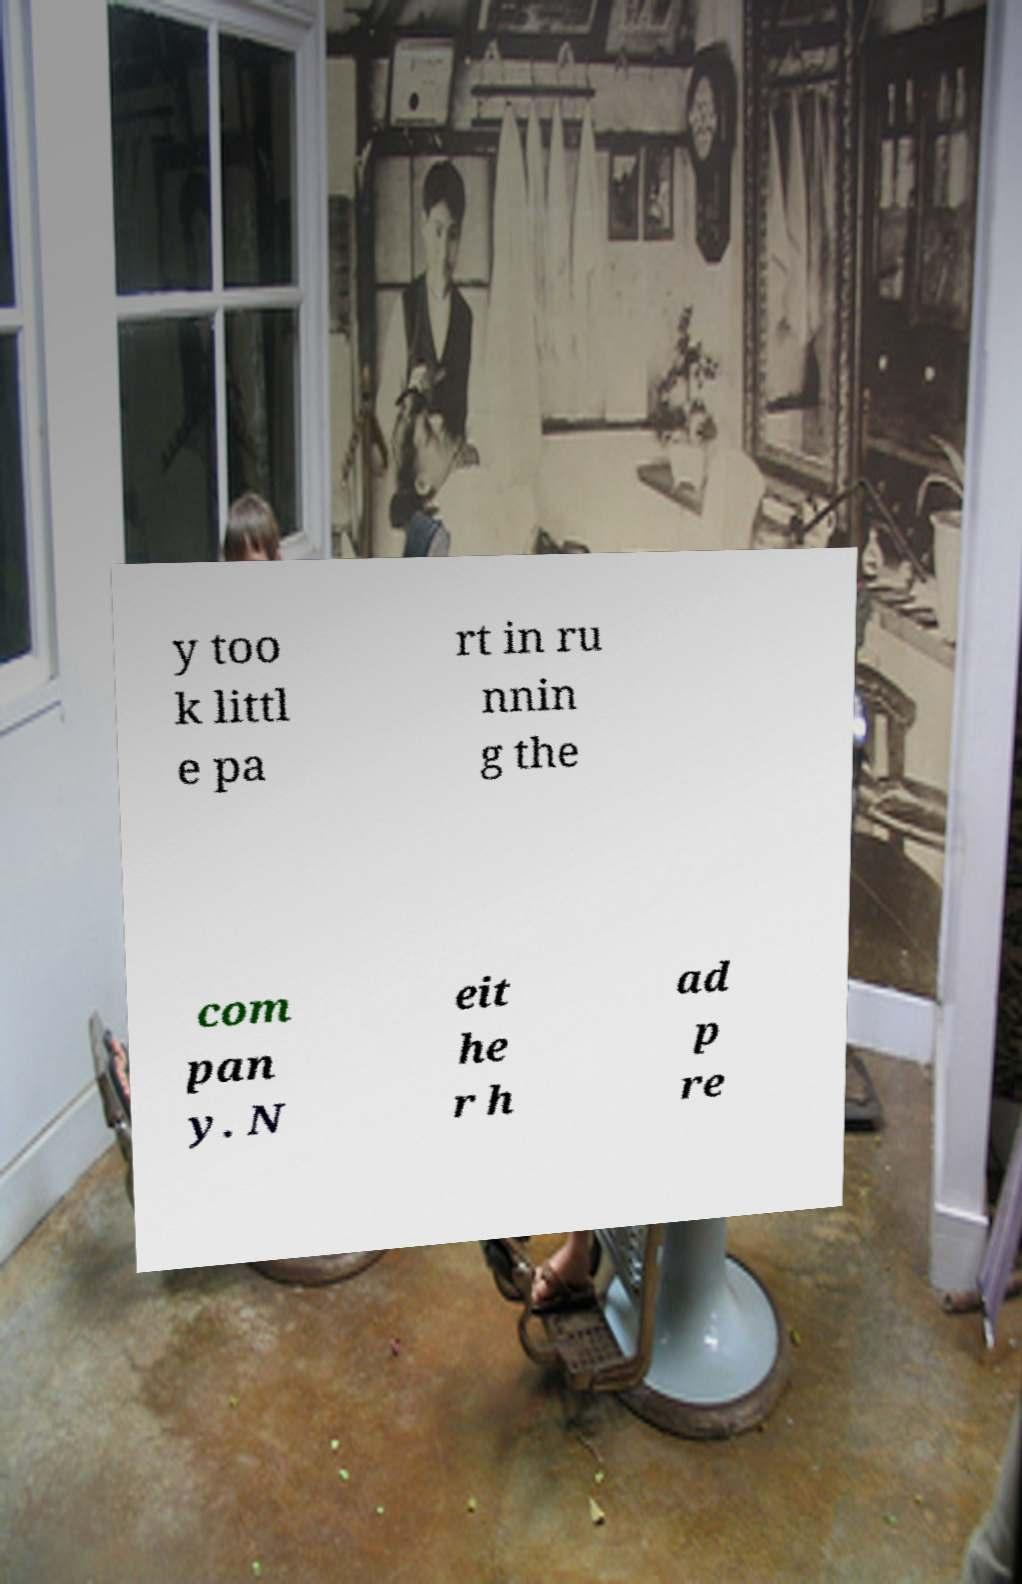I need the written content from this picture converted into text. Can you do that? y too k littl e pa rt in ru nnin g the com pan y. N eit he r h ad p re 